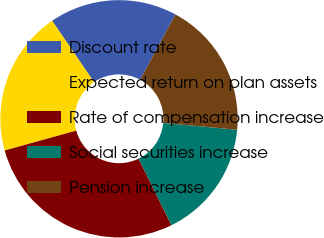Convert chart. <chart><loc_0><loc_0><loc_500><loc_500><pie_chart><fcel>Discount rate<fcel>Expected return on plan assets<fcel>Rate of compensation increase<fcel>Social securities increase<fcel>Pension increase<nl><fcel>17.42%<fcel>19.77%<fcel>27.98%<fcel>16.25%<fcel>18.59%<nl></chart> 